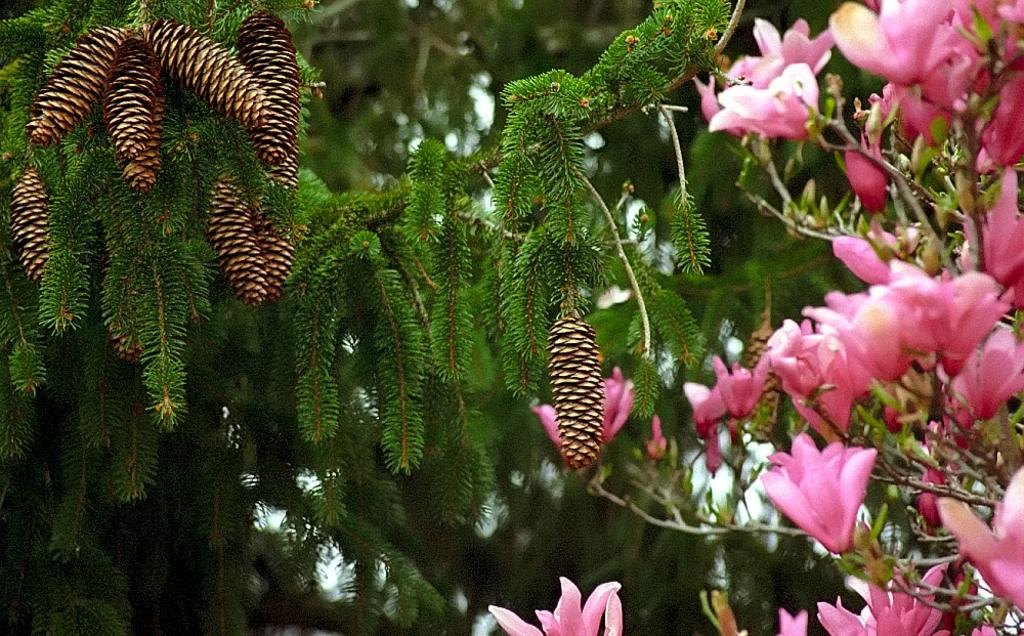What type of vegetation can be seen in the image? There are trees in the image. Where are the flowers located in the image? The flowers are on the right side of the image. How many cherries are hanging from the trees in the image? There are no cherries visible in the image; only trees and flowers are present. What type of dock can be seen in the middle of the image? There is no dock present in the image; it only features trees and flowers. 